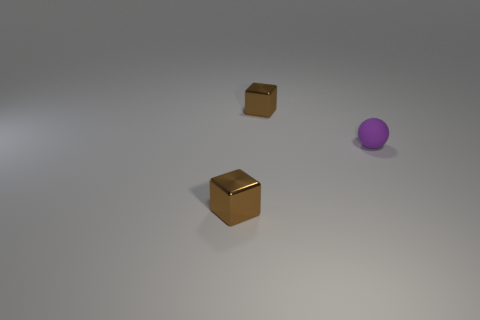How might the arrangement of objects convey a sense of space or depth? The spatial arrangement of the objects—the metallic cube up front, the cardboard cube slightly behind and to the left, and the purple sphere further back to the right—creates a diagonal line that draws the eye through the image. Their varying distances from the viewer, along with the size perspective and overlapping positions, effectively convey depth in the scene. 